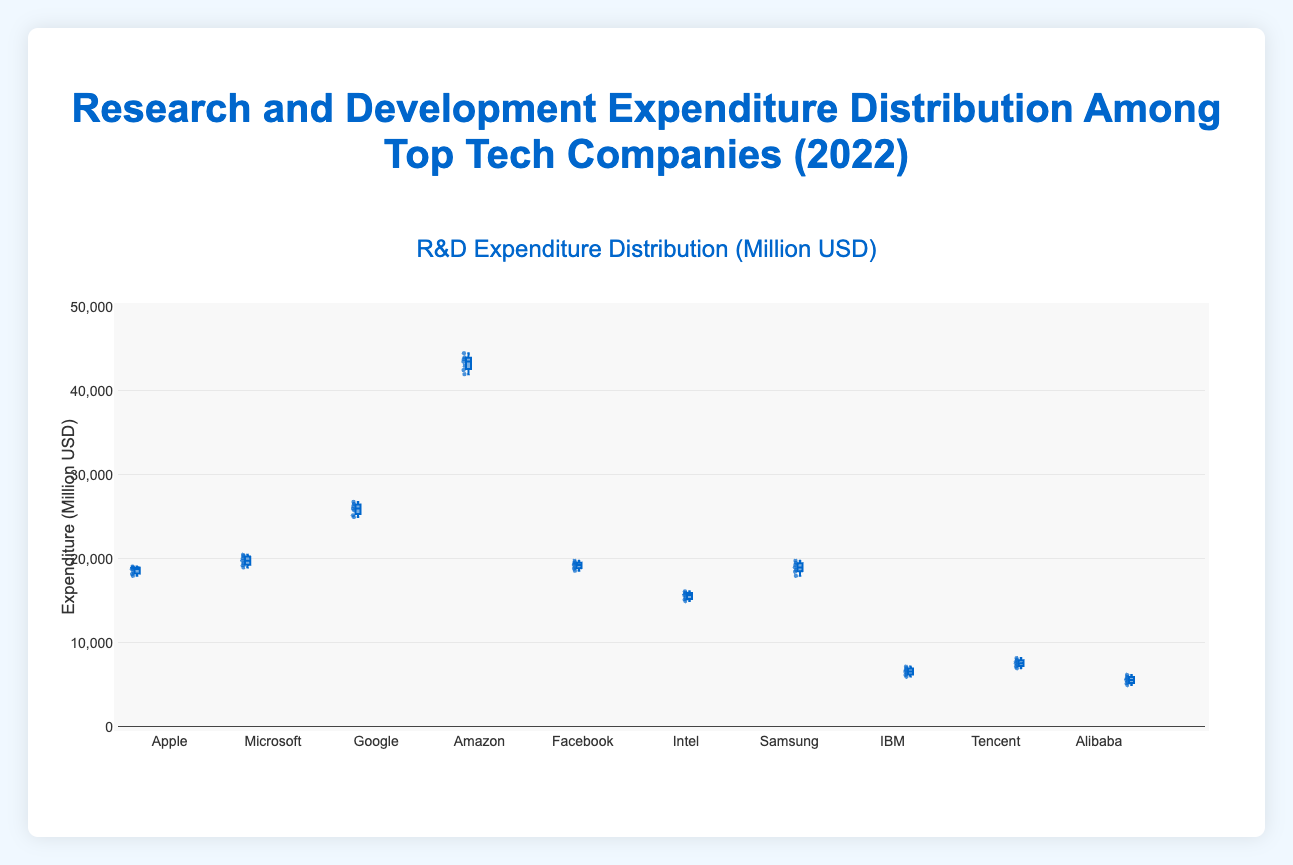What's the title of the figure? The title is displayed prominently at the top of the figure. It reads "Research and Development Expenditure Distribution Among Top Tech Companies (2022)"
Answer: Research and Development Expenditure Distribution Among Top Tech Companies (2022) Which company has the highest median R&D expenditure? The median can be found as the line in the middle of each box. Amazon's box has the highest median line position compared to others.
Answer: Amazon Compare the interquartile ranges of Microsoft and Facebook. Which has a larger range? The interquartile range (IQR) is the distance between the first quartile (bottom of the box) and the third quartile (top of the box). Measuring these visually from the plot, Microsoft's box appears taller than Facebook's, indicating a larger IQR.
Answer: Microsoft What's the range of Amazon's R&D expenditure? The range is the difference between the maximum and minimum values. For Amazon, the minimum value is 42000 and the maximum value is 44500. Therefore, the range is 44500 - 42000 = 2500.
Answer: 2500 Which company has the smallest range in R&D expenditure? By comparing the height of the boxes, Alibaba has the smallest range as its box is the shortest.
Answer: Alibaba What's the correlation between a company's median R&D expenditure and its overall range of expenditures? Observing the plot, companies with higher median expenditures (like Amazon) tend to have larger ranges, while those with lower medians (like IBM) have smaller ranges. This suggests a positive correlation.
Answer: Positive correlation How does Google's R&D expenditure distribution compare to Samsung's in terms of spread and median? Google has a higher median than Samsung, as the middle line of Google's box is higher. Google's IQR is also larger compared to Samsung, indicating a wider spread.
Answer: Google has a higher median and wider spread What is the median R&D expenditure of IBM? The median is found at the middle line of the box. For IBM, it is approximately 6600.
Answer: 6600 By just looking at the box colors, can you deduce any information about the R&D expenditures? All boxes have similar colors, indicating no additional information could be derived about the expenditures based on color alone.
Answer: No additional information Among the listed companies, which shows the most consistent R&D expenditure? Consistency can be interpreted as having the smallest range (difference between maximum and minimum). Alibaba shows the smallest range, indicating the most consistent expenditure.
Answer: Alibaba 